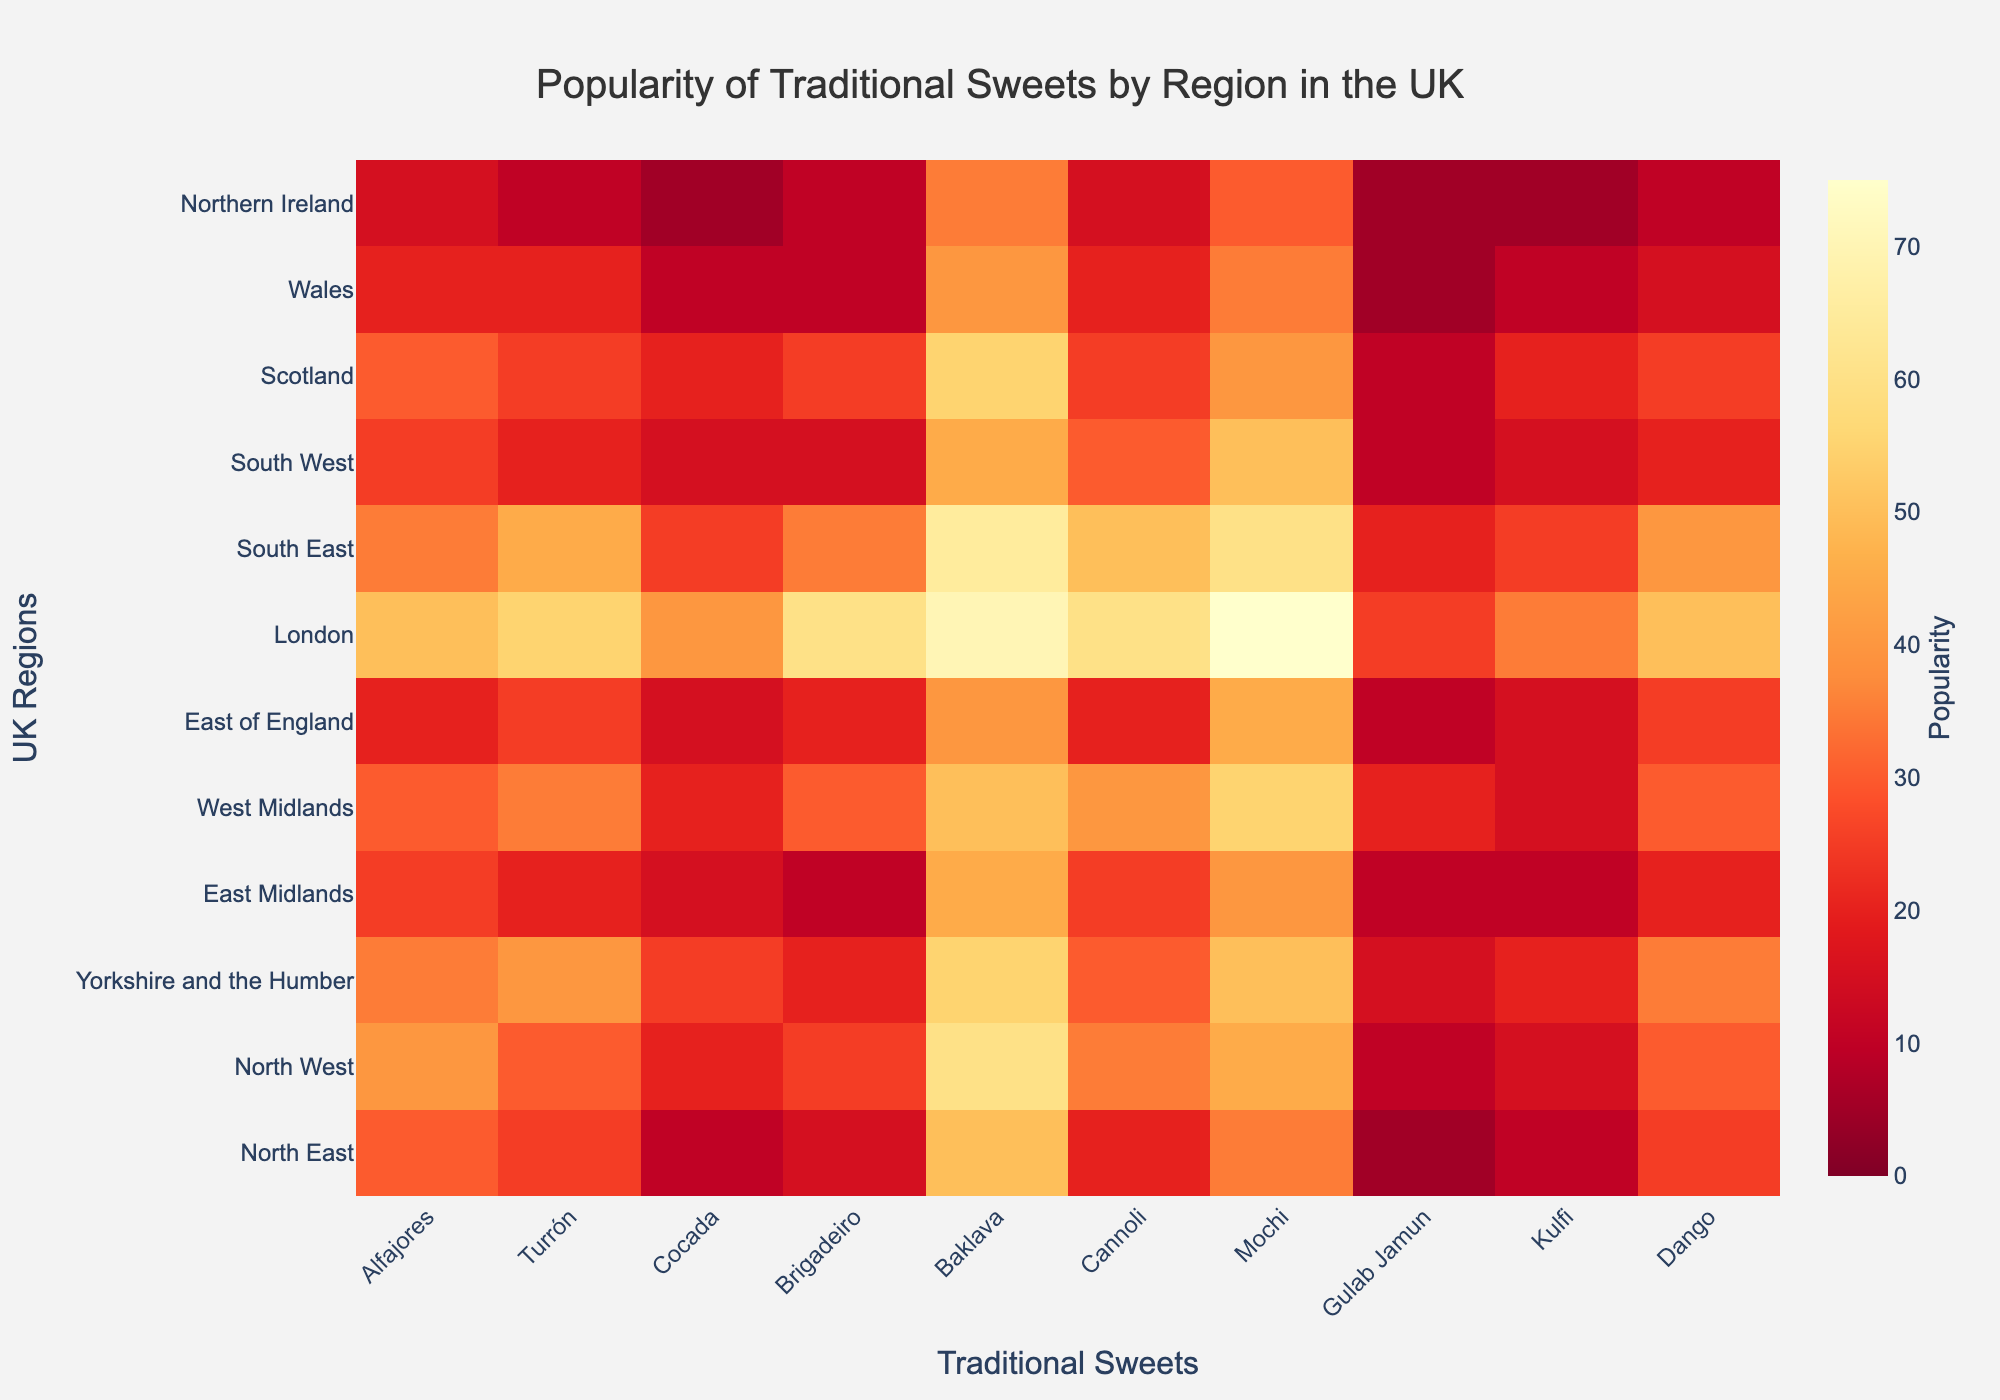What is the most popular sweet in London? Look at the row for London and find the highest value. The highest value in the London row is associated with Mochi, which has a popularity of 75.
Answer: Mochi Which region has the least popularity for Turrón? Check the column for Turrón and find the lowest value. Northern Ireland has the lowest value of 10 in the Turrón column.
Answer: Northern Ireland Which region shows equal popularity for both Gulab Jamun and Kulfi? Compare the values of Gulab Jamun and Kulfi across each region to find equal values. In the East Midlands, both Gulab Jamun and Kulfi have a popularity of 10.
Answer: East Midlands What is the average popularity of Baklava across all regions? Sum the popularity values of Baklava across all regions: (50+60+55+45+50+40+70+65+45+55+40+35) = 610. There are 12 regions, so the average is 610/12 ≈ 50.83.
Answer: 50.83 Compare the popularity of Cannoli in the South East and South West regions. Which region shows a higher preference? Look at the values for Cannoli in the South East (50) and South West (30). The South East has a higher popularity score.
Answer: South East Which region has the highest average popularity for all sweets? Calculate the average popularity for each region by summing all sweet scores and dividing by the number of sweets. The region with the highest value is London, with an average popularity (sum of values 495, divided by 10 sweets) = 49.5.
Answer: London What is the difference in popularity for Brigadeiro between the North West and Wales? Look at the values for Brigadeiro in the North West (25) and Wales (10), then subtract the smaller value from the larger one. 25 - 10 = 15.
Answer: 15 Is Baklava more popular in the East of England or Scotland? Compare the values of Baklava for East of England (40) and Scotland (55). Scotland has a higher value.
Answer: Scotland Does any region have a popularity score of 30 or more for every sweet? Check each row to see if all values are 30 or higher. Only London has all values at or above 30.
Answer: London What is the total popularity of Alfajores in all regions combined? Sum the values for Alfajores across all regions: 30+40+35+25+30+20+50+35+25+30+20+15 = 355.
Answer: 355 